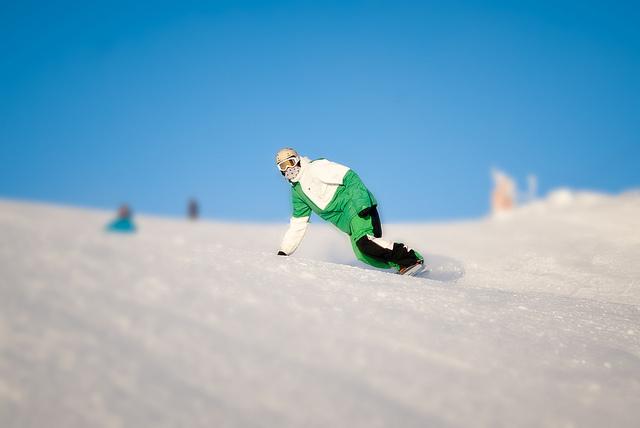What color is that man wearing?
Quick response, please. Green. Is this person riding on a snowboard while wearing green?
Keep it brief. Yes. Is this person wearing a snowsuit?
Quick response, please. Yes. 